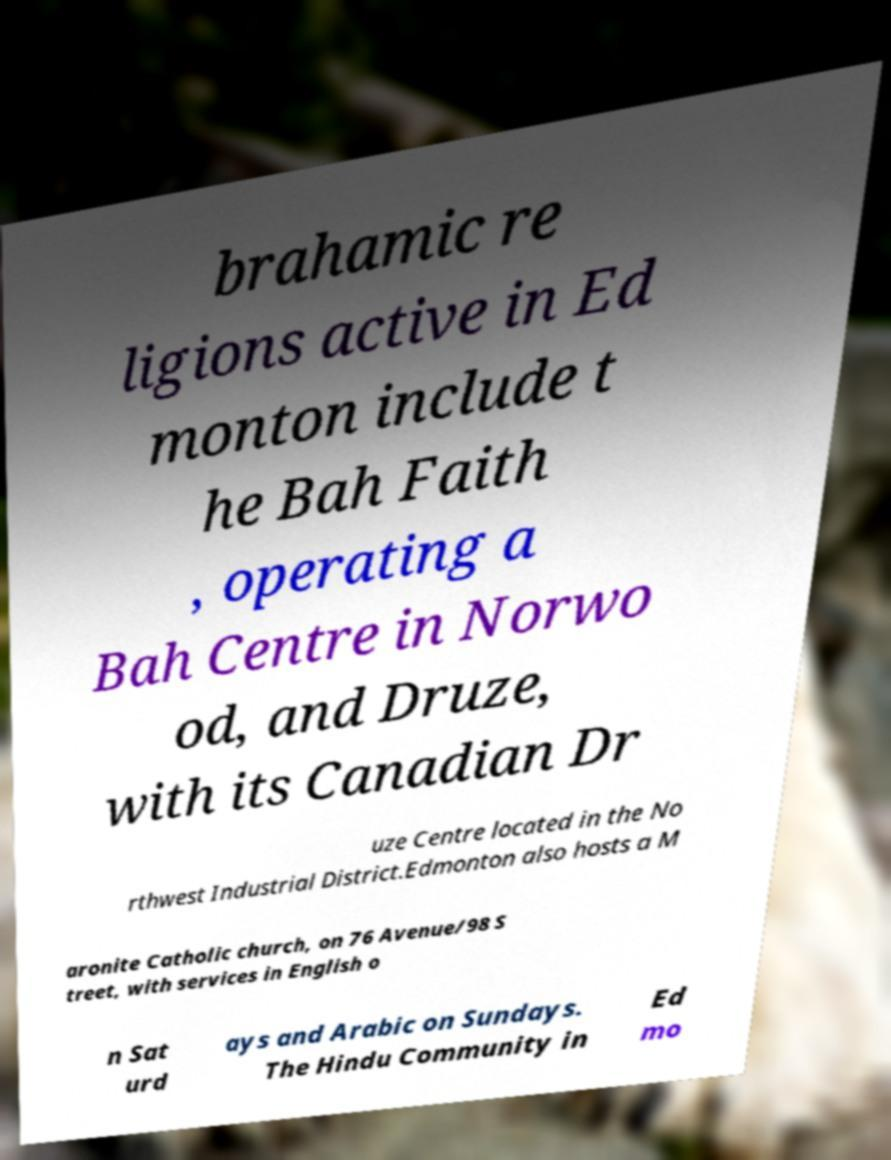Can you read and provide the text displayed in the image?This photo seems to have some interesting text. Can you extract and type it out for me? brahamic re ligions active in Ed monton include t he Bah Faith , operating a Bah Centre in Norwo od, and Druze, with its Canadian Dr uze Centre located in the No rthwest Industrial District.Edmonton also hosts a M aronite Catholic church, on 76 Avenue/98 S treet, with services in English o n Sat urd ays and Arabic on Sundays. The Hindu Community in Ed mo 